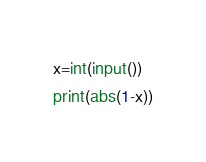Convert code to text. <code><loc_0><loc_0><loc_500><loc_500><_Python_>x=int(input())
print(abs(1-x))</code> 